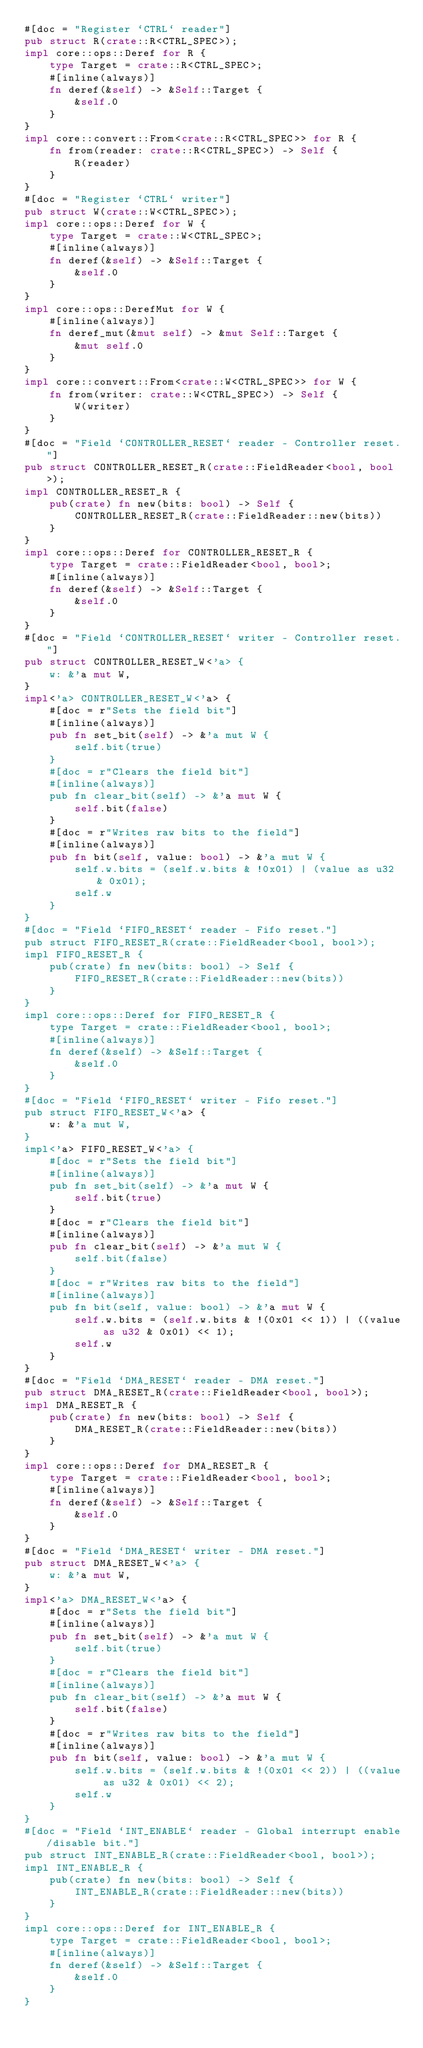Convert code to text. <code><loc_0><loc_0><loc_500><loc_500><_Rust_>#[doc = "Register `CTRL` reader"]
pub struct R(crate::R<CTRL_SPEC>);
impl core::ops::Deref for R {
    type Target = crate::R<CTRL_SPEC>;
    #[inline(always)]
    fn deref(&self) -> &Self::Target {
        &self.0
    }
}
impl core::convert::From<crate::R<CTRL_SPEC>> for R {
    fn from(reader: crate::R<CTRL_SPEC>) -> Self {
        R(reader)
    }
}
#[doc = "Register `CTRL` writer"]
pub struct W(crate::W<CTRL_SPEC>);
impl core::ops::Deref for W {
    type Target = crate::W<CTRL_SPEC>;
    #[inline(always)]
    fn deref(&self) -> &Self::Target {
        &self.0
    }
}
impl core::ops::DerefMut for W {
    #[inline(always)]
    fn deref_mut(&mut self) -> &mut Self::Target {
        &mut self.0
    }
}
impl core::convert::From<crate::W<CTRL_SPEC>> for W {
    fn from(writer: crate::W<CTRL_SPEC>) -> Self {
        W(writer)
    }
}
#[doc = "Field `CONTROLLER_RESET` reader - Controller reset."]
pub struct CONTROLLER_RESET_R(crate::FieldReader<bool, bool>);
impl CONTROLLER_RESET_R {
    pub(crate) fn new(bits: bool) -> Self {
        CONTROLLER_RESET_R(crate::FieldReader::new(bits))
    }
}
impl core::ops::Deref for CONTROLLER_RESET_R {
    type Target = crate::FieldReader<bool, bool>;
    #[inline(always)]
    fn deref(&self) -> &Self::Target {
        &self.0
    }
}
#[doc = "Field `CONTROLLER_RESET` writer - Controller reset."]
pub struct CONTROLLER_RESET_W<'a> {
    w: &'a mut W,
}
impl<'a> CONTROLLER_RESET_W<'a> {
    #[doc = r"Sets the field bit"]
    #[inline(always)]
    pub fn set_bit(self) -> &'a mut W {
        self.bit(true)
    }
    #[doc = r"Clears the field bit"]
    #[inline(always)]
    pub fn clear_bit(self) -> &'a mut W {
        self.bit(false)
    }
    #[doc = r"Writes raw bits to the field"]
    #[inline(always)]
    pub fn bit(self, value: bool) -> &'a mut W {
        self.w.bits = (self.w.bits & !0x01) | (value as u32 & 0x01);
        self.w
    }
}
#[doc = "Field `FIFO_RESET` reader - Fifo reset."]
pub struct FIFO_RESET_R(crate::FieldReader<bool, bool>);
impl FIFO_RESET_R {
    pub(crate) fn new(bits: bool) -> Self {
        FIFO_RESET_R(crate::FieldReader::new(bits))
    }
}
impl core::ops::Deref for FIFO_RESET_R {
    type Target = crate::FieldReader<bool, bool>;
    #[inline(always)]
    fn deref(&self) -> &Self::Target {
        &self.0
    }
}
#[doc = "Field `FIFO_RESET` writer - Fifo reset."]
pub struct FIFO_RESET_W<'a> {
    w: &'a mut W,
}
impl<'a> FIFO_RESET_W<'a> {
    #[doc = r"Sets the field bit"]
    #[inline(always)]
    pub fn set_bit(self) -> &'a mut W {
        self.bit(true)
    }
    #[doc = r"Clears the field bit"]
    #[inline(always)]
    pub fn clear_bit(self) -> &'a mut W {
        self.bit(false)
    }
    #[doc = r"Writes raw bits to the field"]
    #[inline(always)]
    pub fn bit(self, value: bool) -> &'a mut W {
        self.w.bits = (self.w.bits & !(0x01 << 1)) | ((value as u32 & 0x01) << 1);
        self.w
    }
}
#[doc = "Field `DMA_RESET` reader - DMA reset."]
pub struct DMA_RESET_R(crate::FieldReader<bool, bool>);
impl DMA_RESET_R {
    pub(crate) fn new(bits: bool) -> Self {
        DMA_RESET_R(crate::FieldReader::new(bits))
    }
}
impl core::ops::Deref for DMA_RESET_R {
    type Target = crate::FieldReader<bool, bool>;
    #[inline(always)]
    fn deref(&self) -> &Self::Target {
        &self.0
    }
}
#[doc = "Field `DMA_RESET` writer - DMA reset."]
pub struct DMA_RESET_W<'a> {
    w: &'a mut W,
}
impl<'a> DMA_RESET_W<'a> {
    #[doc = r"Sets the field bit"]
    #[inline(always)]
    pub fn set_bit(self) -> &'a mut W {
        self.bit(true)
    }
    #[doc = r"Clears the field bit"]
    #[inline(always)]
    pub fn clear_bit(self) -> &'a mut W {
        self.bit(false)
    }
    #[doc = r"Writes raw bits to the field"]
    #[inline(always)]
    pub fn bit(self, value: bool) -> &'a mut W {
        self.w.bits = (self.w.bits & !(0x01 << 2)) | ((value as u32 & 0x01) << 2);
        self.w
    }
}
#[doc = "Field `INT_ENABLE` reader - Global interrupt enable/disable bit."]
pub struct INT_ENABLE_R(crate::FieldReader<bool, bool>);
impl INT_ENABLE_R {
    pub(crate) fn new(bits: bool) -> Self {
        INT_ENABLE_R(crate::FieldReader::new(bits))
    }
}
impl core::ops::Deref for INT_ENABLE_R {
    type Target = crate::FieldReader<bool, bool>;
    #[inline(always)]
    fn deref(&self) -> &Self::Target {
        &self.0
    }
}</code> 